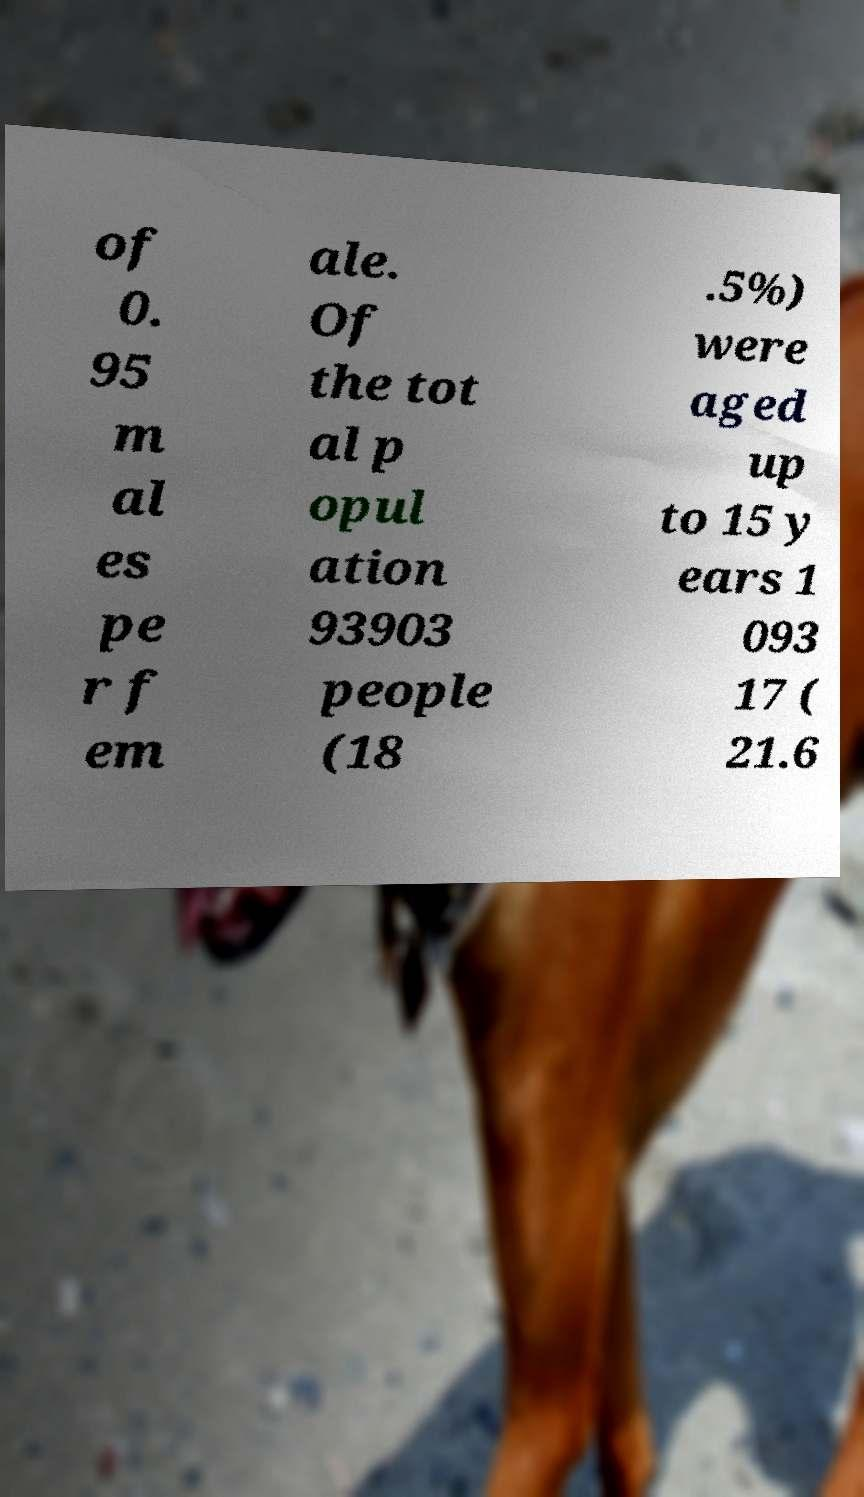Could you extract and type out the text from this image? of 0. 95 m al es pe r f em ale. Of the tot al p opul ation 93903 people (18 .5%) were aged up to 15 y ears 1 093 17 ( 21.6 